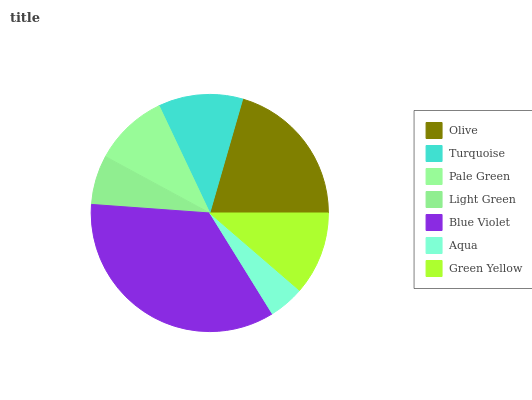Is Aqua the minimum?
Answer yes or no. Yes. Is Blue Violet the maximum?
Answer yes or no. Yes. Is Turquoise the minimum?
Answer yes or no. No. Is Turquoise the maximum?
Answer yes or no. No. Is Olive greater than Turquoise?
Answer yes or no. Yes. Is Turquoise less than Olive?
Answer yes or no. Yes. Is Turquoise greater than Olive?
Answer yes or no. No. Is Olive less than Turquoise?
Answer yes or no. No. Is Green Yellow the high median?
Answer yes or no. Yes. Is Green Yellow the low median?
Answer yes or no. Yes. Is Olive the high median?
Answer yes or no. No. Is Olive the low median?
Answer yes or no. No. 